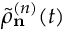Convert formula to latex. <formula><loc_0><loc_0><loc_500><loc_500>\tilde { \rho } _ { n } ^ { ( n ) } ( t )</formula> 